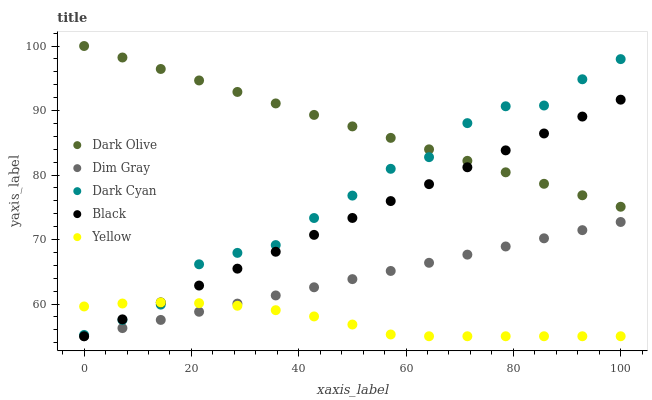Does Yellow have the minimum area under the curve?
Answer yes or no. Yes. Does Dark Olive have the maximum area under the curve?
Answer yes or no. Yes. Does Dim Gray have the minimum area under the curve?
Answer yes or no. No. Does Dim Gray have the maximum area under the curve?
Answer yes or no. No. Is Dim Gray the smoothest?
Answer yes or no. Yes. Is Dark Cyan the roughest?
Answer yes or no. Yes. Is Dark Olive the smoothest?
Answer yes or no. No. Is Dark Olive the roughest?
Answer yes or no. No. Does Dim Gray have the lowest value?
Answer yes or no. Yes. Does Dark Olive have the lowest value?
Answer yes or no. No. Does Dark Olive have the highest value?
Answer yes or no. Yes. Does Dim Gray have the highest value?
Answer yes or no. No. Is Dim Gray less than Dark Cyan?
Answer yes or no. Yes. Is Dark Cyan greater than Dim Gray?
Answer yes or no. Yes. Does Black intersect Dark Olive?
Answer yes or no. Yes. Is Black less than Dark Olive?
Answer yes or no. No. Is Black greater than Dark Olive?
Answer yes or no. No. Does Dim Gray intersect Dark Cyan?
Answer yes or no. No. 